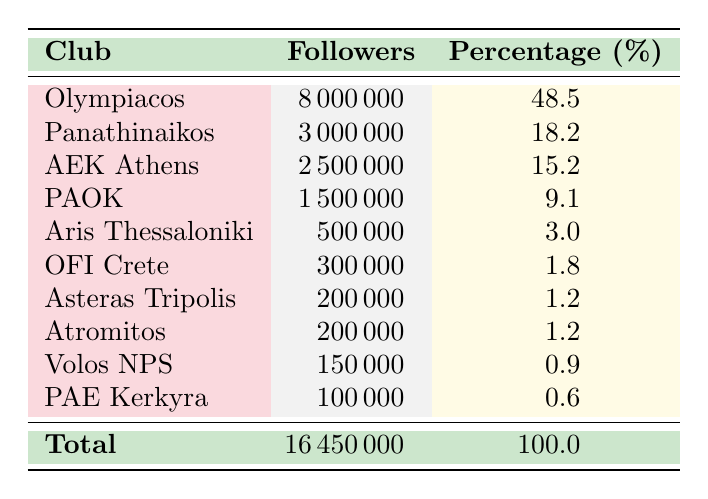What football club has the highest number of followers? Olympiacos is listed with 8,000,000 followers in the table, which is greater than that of any other club.
Answer: Olympiacos What percentage of the total followers do PAOK fans represent? PAOK has 1,500,000 followers, and the total number of followers is 16,450,000. To find the percentage: (1,500,000 / 16,450,000) * 100 = 9.1%.
Answer: 9.1% Which club has fewer followers: Asteras Tripolis or Volos NPS? Asteras Tripolis has 200,000 followers while Volos NPS has 150,000 followers. Comparing the two shows Asteras Tripolis has more followers.
Answer: Asteras Tripolis What is the total number of followers for the clubs listed in the table? The total number of followers is given at the bottom of the table as 16,450,000, which is the sum of all listed followers.
Answer: 16,450,000 Are there more clubs with followers below 1,000,000 or above 1,000,000? There are six clubs with fewer than 1,000,000 followers: Aris Thessaloniki, OFI Crete, Asteras Tripolis, Atromitos, Volos NPS, and PAE Kerkyra. There are four clubs with over 1,000,000 followers. Thus, there are more clubs below 1,000,000 followers.
Answer: Yes What is the combined number of followers for Panathinaikos and AEK Athens? Adding the followers of Panathinaikos (3,000,000) and AEK Athens (2,500,000) gives a total of 5,500,000 followers (3,000,000 + 2,500,000 = 5,500,000).
Answer: 5,500,000 Is the percentage of followers for Olympiacos more than half of the total? The percentage for Olympiacos is 48.5%, which is less than 50%, meaning it does not constitute more than half of the total followers.
Answer: No How many clubs have more than 1,000,000 followers? The clubs with more than 1,000,000 followers are Olympiacos, Panathinaikos, AEK Athens, and PAOK, totaling four clubs.
Answer: 4 What is the difference in followers between Olympiacos and PAOK? Olympiacos has 8,000,000 followers while PAOK has 1,500,000 followers. The difference in followers is 8,000,000 - 1,500,000 = 6,500,000.
Answer: 6,500,000 